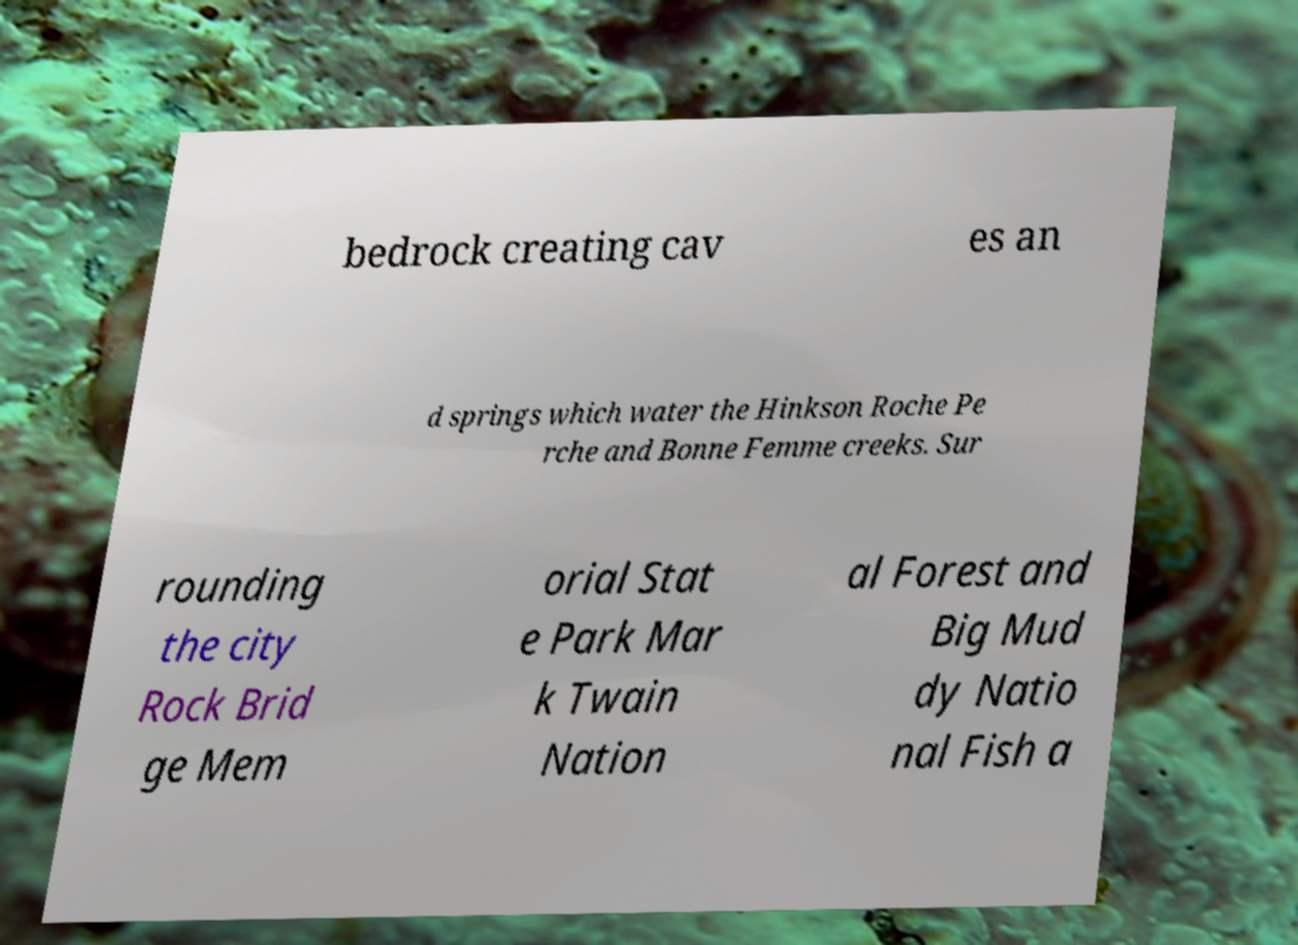Could you extract and type out the text from this image? bedrock creating cav es an d springs which water the Hinkson Roche Pe rche and Bonne Femme creeks. Sur rounding the city Rock Brid ge Mem orial Stat e Park Mar k Twain Nation al Forest and Big Mud dy Natio nal Fish a 